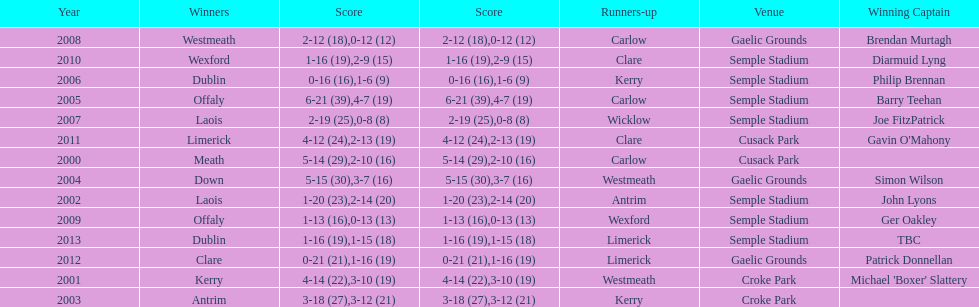Give me the full table as a dictionary. {'header': ['Year', 'Winners', 'Score', 'Score', 'Runners-up', 'Venue', 'Winning Captain'], 'rows': [['2008', 'Westmeath', '2-12 (18)', '0-12 (12)', 'Carlow', 'Gaelic Grounds', 'Brendan Murtagh'], ['2010', 'Wexford', '1-16 (19)', '2-9 (15)', 'Clare', 'Semple Stadium', 'Diarmuid Lyng'], ['2006', 'Dublin', '0-16 (16)', '1-6 (9)', 'Kerry', 'Semple Stadium', 'Philip Brennan'], ['2005', 'Offaly', '6-21 (39)', '4-7 (19)', 'Carlow', 'Semple Stadium', 'Barry Teehan'], ['2007', 'Laois', '2-19 (25)', '0-8 (8)', 'Wicklow', 'Semple Stadium', 'Joe FitzPatrick'], ['2011', 'Limerick', '4-12 (24)', '2-13 (19)', 'Clare', 'Cusack Park', "Gavin O'Mahony"], ['2000', 'Meath', '5-14 (29)', '2-10 (16)', 'Carlow', 'Cusack Park', ''], ['2004', 'Down', '5-15 (30)', '3-7 (16)', 'Westmeath', 'Gaelic Grounds', 'Simon Wilson'], ['2002', 'Laois', '1-20 (23)', '2-14 (20)', 'Antrim', 'Semple Stadium', 'John Lyons'], ['2009', 'Offaly', '1-13 (16)', '0-13 (13)', 'Wexford', 'Semple Stadium', 'Ger Oakley'], ['2013', 'Dublin', '1-16 (19)', '1-15 (18)', 'Limerick', 'Semple Stadium', 'TBC'], ['2012', 'Clare', '0-21 (21)', '1-16 (19)', 'Limerick', 'Gaelic Grounds', 'Patrick Donnellan'], ['2001', 'Kerry', '4-14 (22)', '3-10 (19)', 'Westmeath', 'Croke Park', "Michael 'Boxer' Slattery"], ['2003', 'Antrim', '3-18 (27)', '3-12 (21)', 'Kerry', 'Croke Park', '']]} How many times was carlow the runner-up? 3. 